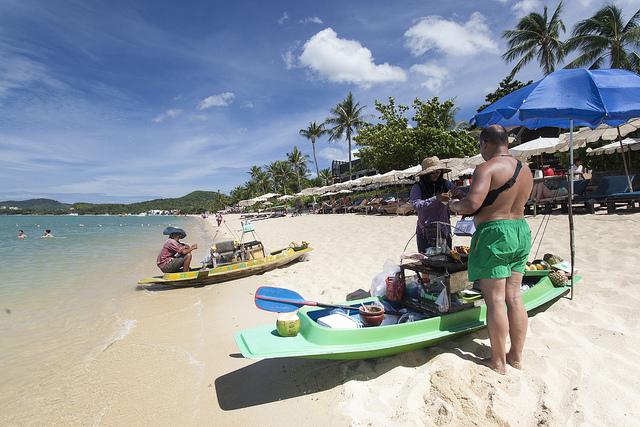How many clouds can be seen in the sky?
Concise answer only. 4. What color is the umbrella?
Short answer required. Blue. Are the people about to go swimming?
Answer briefly. No. Is there a blue trash can?
Give a very brief answer. No. What color are the man's shorts?
Answer briefly. Green. What is this person riding?
Write a very short answer. Boat. What is the man doing?
Concise answer only. Standing. What things are inside the small boat?
Write a very short answer. Food. 